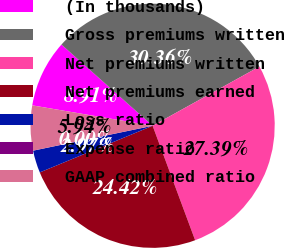Convert chart. <chart><loc_0><loc_0><loc_500><loc_500><pie_chart><fcel>(In thousands)<fcel>Gross premiums written<fcel>Net premiums written<fcel>Net premiums earned<fcel>Loss ratio<fcel>Expense ratio<fcel>GAAP combined ratio<nl><fcel>8.91%<fcel>30.36%<fcel>27.39%<fcel>24.42%<fcel>2.97%<fcel>0.0%<fcel>5.94%<nl></chart> 